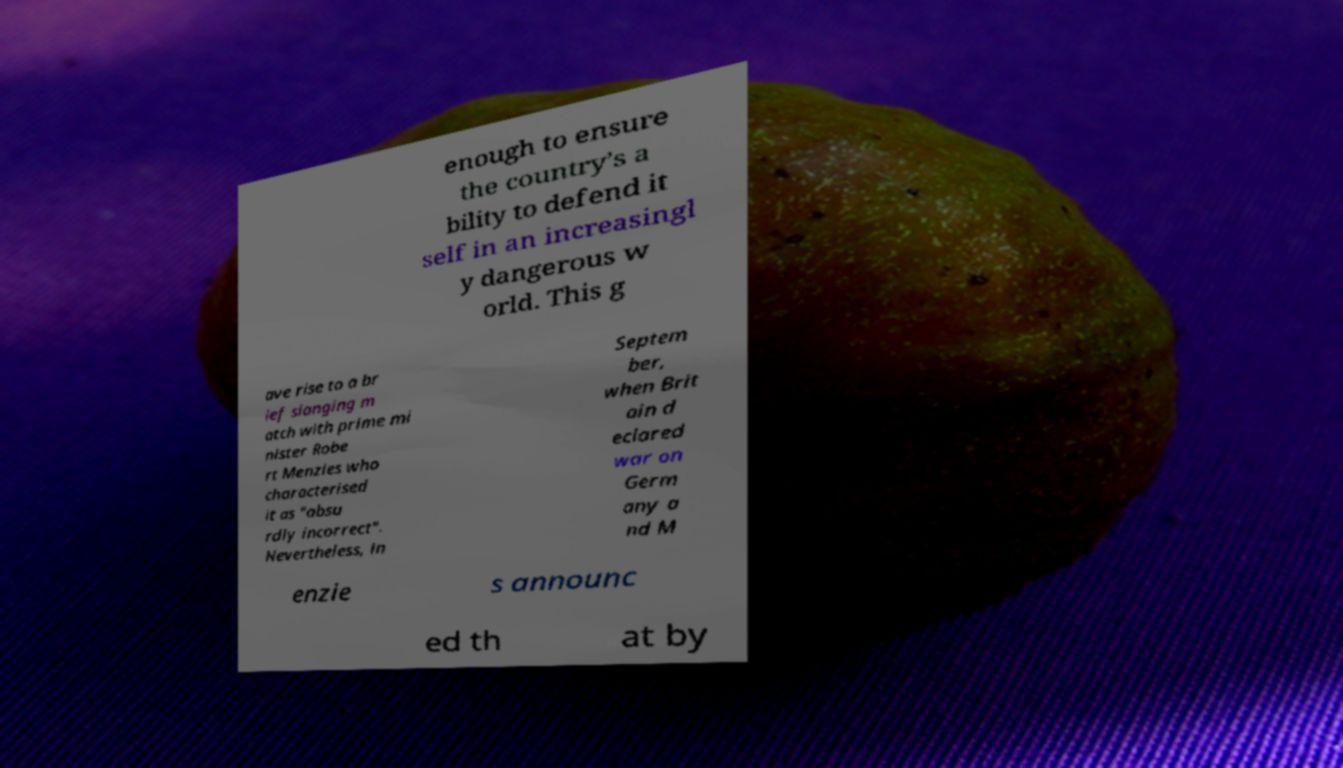Can you read and provide the text displayed in the image?This photo seems to have some interesting text. Can you extract and type it out for me? enough to ensure the country’s a bility to defend it self in an increasingl y dangerous w orld. This g ave rise to a br ief slanging m atch with prime mi nister Robe rt Menzies who characterised it as "absu rdly incorrect". Nevertheless, in Septem ber, when Brit ain d eclared war on Germ any a nd M enzie s announc ed th at by 